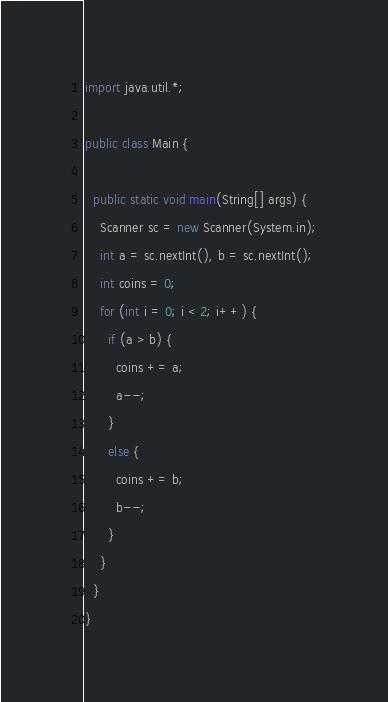Convert code to text. <code><loc_0><loc_0><loc_500><loc_500><_Java_>import java.util.*;

public class Main {
  
  public static void main(String[] args) {
    Scanner sc = new Scanner(System.in);
    int a = sc.nextInt(), b = sc.nextInt();
    int coins = 0;
    for (int i = 0; i < 2; i++) {
      if (a > b) {
        coins += a;
        a--;
      }
      else {
        coins += b;
        b--;
      }
    }
  }
}
</code> 